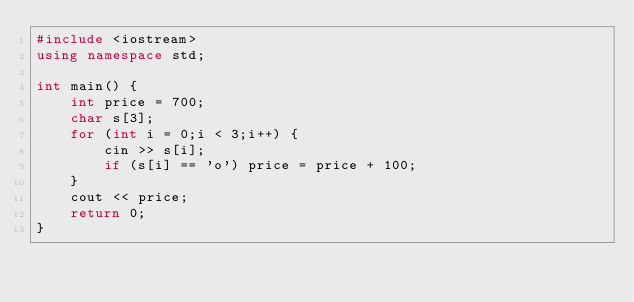Convert code to text. <code><loc_0><loc_0><loc_500><loc_500><_C++_>#include <iostream>
using namespace std;

int main() {
	int price = 700;
	char s[3];
	for (int i = 0;i < 3;i++) {
	    cin >> s[i];
	    if (s[i] == 'o') price = price + 100;
	}
	cout << price;
	return 0;
}
</code> 